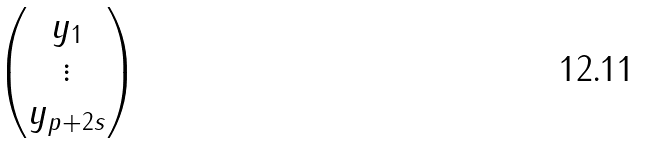Convert formula to latex. <formula><loc_0><loc_0><loc_500><loc_500>\begin{pmatrix} y _ { 1 } \\ \vdots \\ y _ { p + 2 s } \end{pmatrix}</formula> 